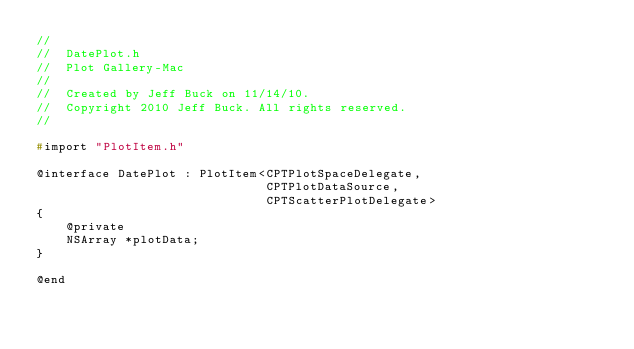<code> <loc_0><loc_0><loc_500><loc_500><_C_>//
//  DatePlot.h
//  Plot Gallery-Mac
//
//  Created by Jeff Buck on 11/14/10.
//  Copyright 2010 Jeff Buck. All rights reserved.
//

#import "PlotItem.h"

@interface DatePlot : PlotItem<CPTPlotSpaceDelegate,
                               CPTPlotDataSource,
                               CPTScatterPlotDelegate>
{
    @private
    NSArray *plotData;
}

@end
</code> 